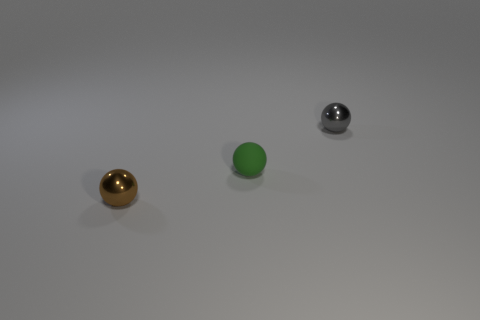Subtract all tiny brown balls. How many balls are left? 2 Add 1 brown metal things. How many objects exist? 4 Subtract all green spheres. How many spheres are left? 2 Subtract 1 spheres. How many spheres are left? 2 Subtract all brown balls. Subtract all purple cubes. How many balls are left? 2 Subtract all big yellow rubber cylinders. Subtract all gray spheres. How many objects are left? 2 Add 1 tiny brown shiny balls. How many tiny brown shiny balls are left? 2 Add 1 tiny purple rubber objects. How many tiny purple rubber objects exist? 1 Subtract 0 red cubes. How many objects are left? 3 